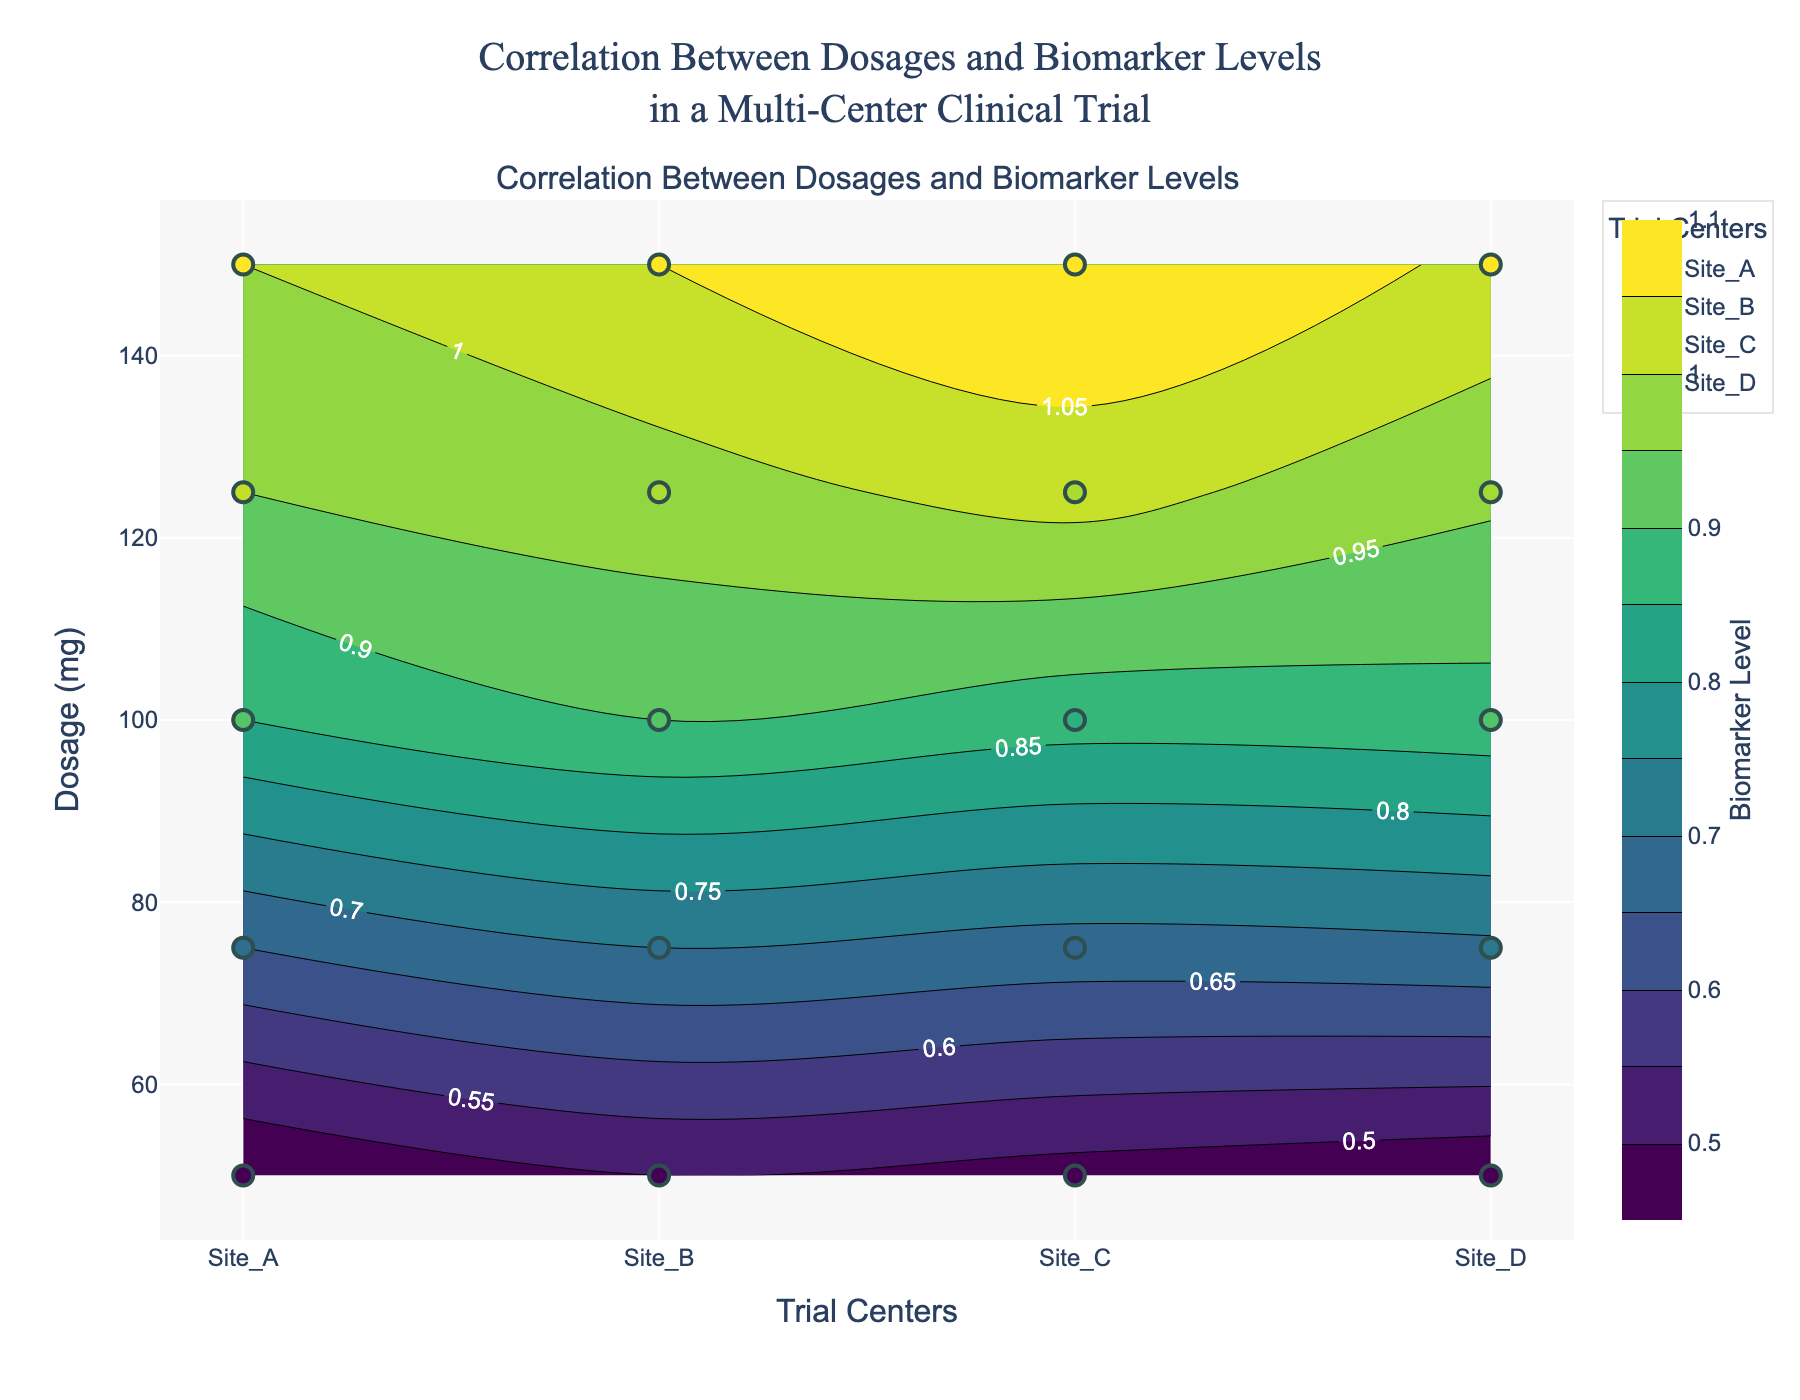What's the title of the figure? The title of the figure is usually shown at the top and provides a summary of what the plot represents. Here, the plot deals with the correlation between dosages and biomarker levels in different trial centers during a clinical trial, and the title reflects that.
Answer: Correlation Between Dosages and Biomarker Levels in a Multi-Center Clinical Trial How is the biomarker level represented in the figure? The biomarker level is depicted using a color scale (Viridis) in the contour plot, with specific levels indicated by labeled contour lines. Additionally, individual data points are color-coded based on their biomarker levels.
Answer: By color scale and labeled contour lines Which trial center shows the highest biomarker level? To determine this, look at the contour levels and the scatter plot points for each center. Site_C has the highest individual biomarker level data point at 1.10.
Answer: Site_C What is the dosage range examined in the trial? The y-axis of the plot indicates the dosage in milligrams. By examining the range of values on the y-axis, it is evident the dosage ranges from 50 mg to 150 mg.
Answer: 50 mg to 150 mg Which center has the most consistent biomarker levels across different dosages? To determine consistency, look at the contour lines and scatter plot points of each center. The more evenly spaced the contour lines and the closer the scatter points, the more consistent the biomarker levels. All centers show fairly consistent trends but Site_B appears particularly smooth and consistent.
Answer: Site_B At 100 mg dosage, which center has the lowest biomarker level? To find the lowest level at 100 mg, check the scatter plot and contour labels at the 100 mg line. Site_D has the lowest biomarker level of 0.88 at 100 mg.
Answer: Site_D How do the biomarker levels vary with increasing dosage in Site_A? Examine the trend of the scatter plot points and the contour lines for Site_A. As the dosage increases from 50 mg to 150 mg, the biomarker levels also rise steadily from 0.45 to 1.00.
Answer: Biomarker levels increase steadily What can be inferred about the variability in biomarker levels across different centers for a dosage of 150 mg? Look at the scatter points at the 150 mg level across centers. The range of biomarker levels varies slightly; going from Site_A (1.00), Site_B (1.05), Site_C (1.10), and Site_D (1.04).
Answer: Biomarker levels show slight variability Which center has the steepest increase in biomarker levels with dosage? Find the center where the slope of biomarker level increase is steepest by comparing the contours and scatter plots. Site_C shows the steepest increase from 0.48 at 50 mg to 1.10 at 150 mg.
Answer: Site_C What is the average biomarker level for the 75 mg dosage across all centers? Identify the biomarker levels at 75 mg for each center and calculate their average: Site_A (0.65), Site_B (0.70), Site_C (0.68), Site_D (0.69). The average is (0.65 + 0.70 + 0.68 + 0.69) / 4 = 0.68.
Answer: 0.68 